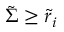Convert formula to latex. <formula><loc_0><loc_0><loc_500><loc_500>\tilde { \Sigma } \geq \tilde { r } _ { i }</formula> 